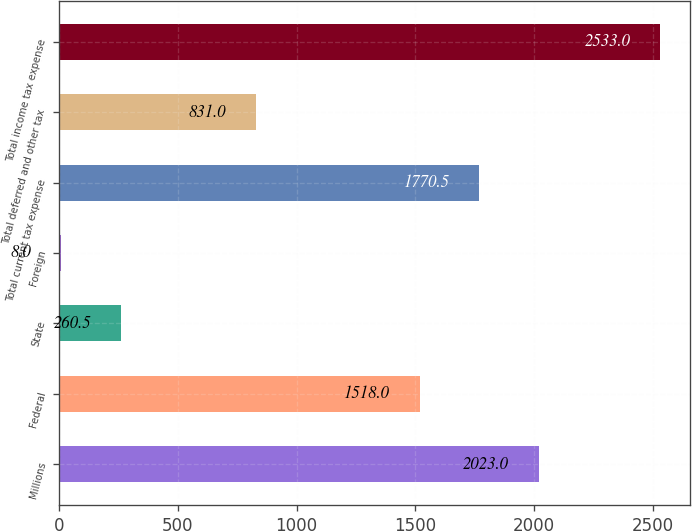Convert chart. <chart><loc_0><loc_0><loc_500><loc_500><bar_chart><fcel>Millions<fcel>Federal<fcel>State<fcel>Foreign<fcel>Total current tax expense<fcel>Total deferred and other tax<fcel>Total income tax expense<nl><fcel>2023<fcel>1518<fcel>260.5<fcel>8<fcel>1770.5<fcel>831<fcel>2533<nl></chart> 